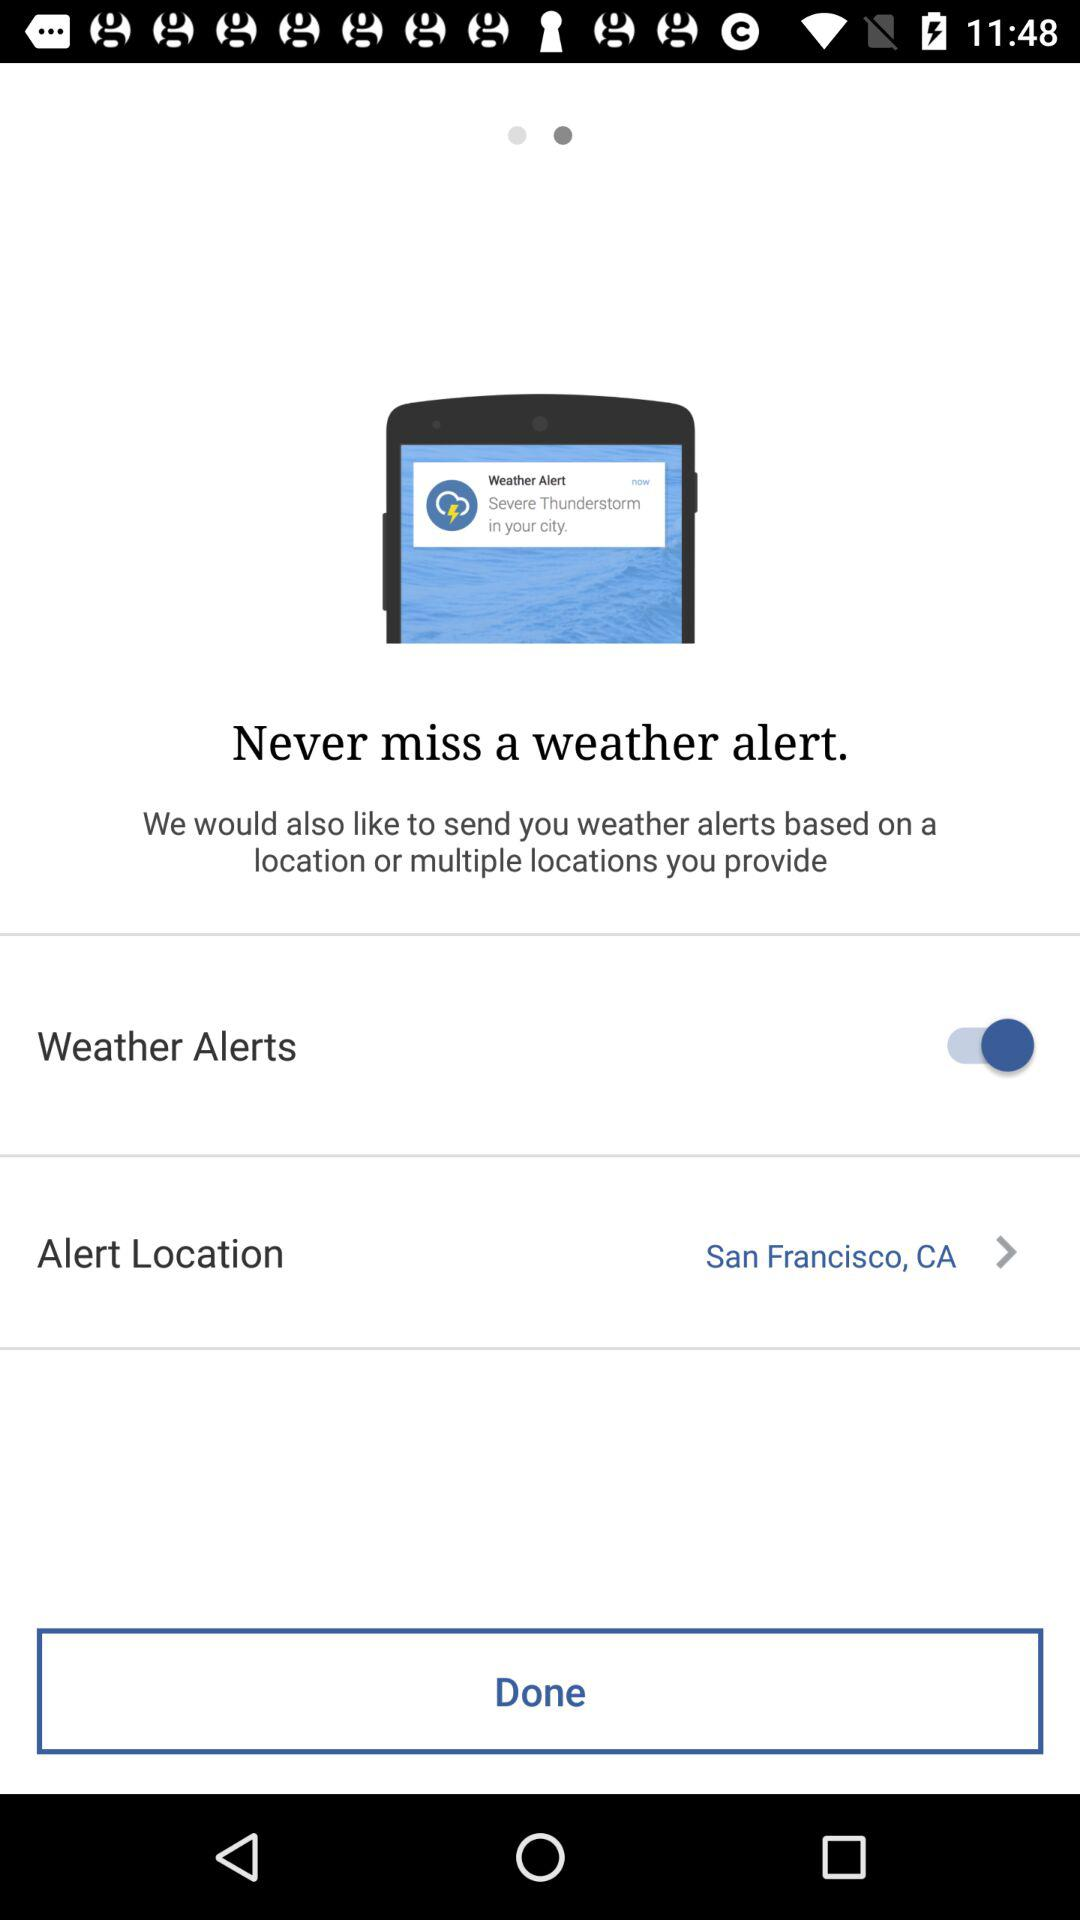What is the status of the weather alerts? The status of the weather alerts is "on". 